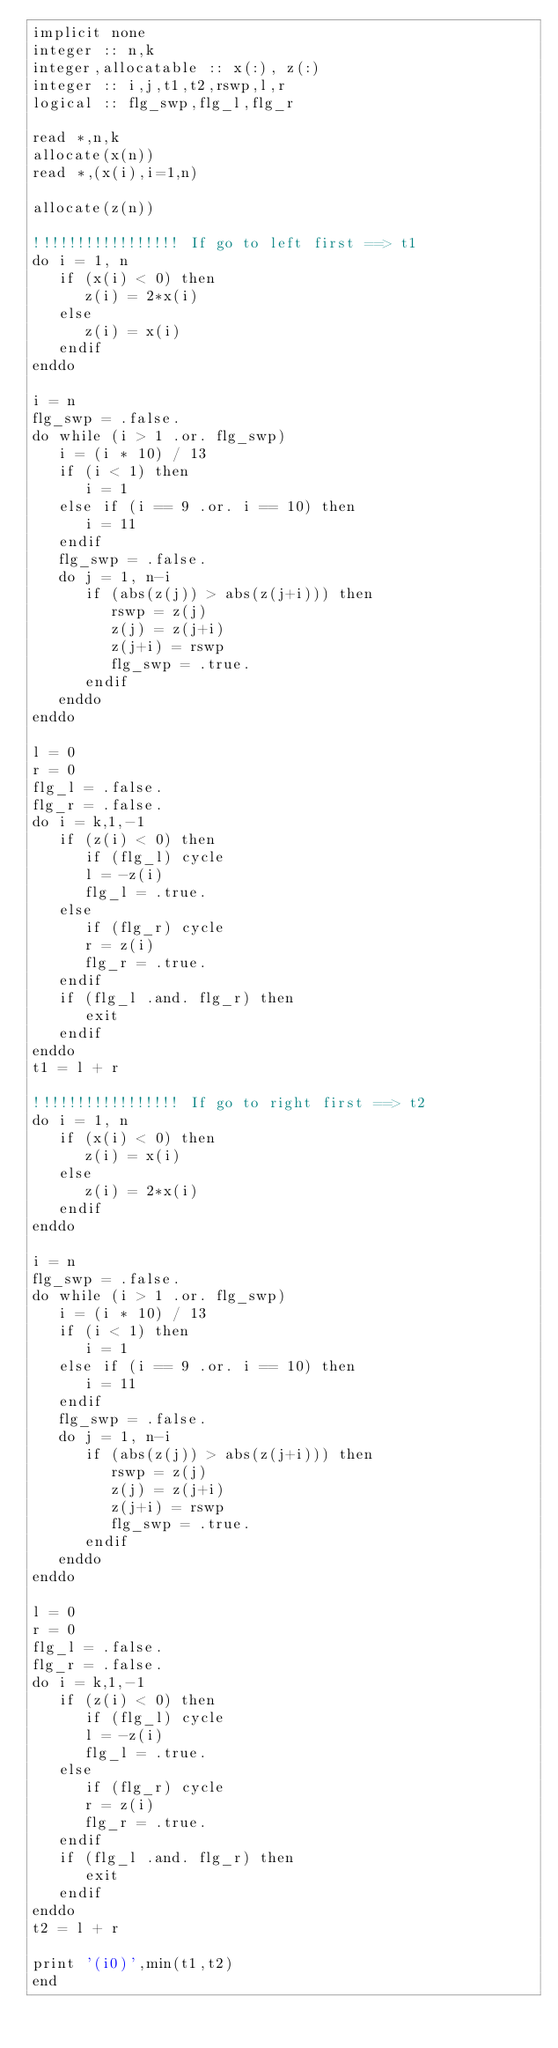Convert code to text. <code><loc_0><loc_0><loc_500><loc_500><_FORTRAN_>implicit none
integer :: n,k
integer,allocatable :: x(:), z(:)
integer :: i,j,t1,t2,rswp,l,r
logical :: flg_swp,flg_l,flg_r

read *,n,k
allocate(x(n))
read *,(x(i),i=1,n)

allocate(z(n))

!!!!!!!!!!!!!!!!! If go to left first ==> t1
do i = 1, n
   if (x(i) < 0) then
      z(i) = 2*x(i)
   else
      z(i) = x(i)
   endif
enddo

i = n
flg_swp = .false.
do while (i > 1 .or. flg_swp)
   i = (i * 10) / 13
   if (i < 1) then
      i = 1
   else if (i == 9 .or. i == 10) then 
      i = 11
   endif
   flg_swp = .false.
   do j = 1, n-i
      if (abs(z(j)) > abs(z(j+i))) then
         rswp = z(j) 
         z(j) = z(j+i)
         z(j+i) = rswp
         flg_swp = .true.
      endif
   enddo
enddo

l = 0
r = 0
flg_l = .false.
flg_r = .false.
do i = k,1,-1
   if (z(i) < 0) then
      if (flg_l) cycle
      l = -z(i)
      flg_l = .true.
   else
      if (flg_r) cycle
      r = z(i)
      flg_r = .true.
   endif
   if (flg_l .and. flg_r) then
      exit
   endif
enddo
t1 = l + r

!!!!!!!!!!!!!!!!! If go to right first ==> t2
do i = 1, n
   if (x(i) < 0) then
      z(i) = x(i)
   else
      z(i) = 2*x(i)
   endif
enddo

i = n
flg_swp = .false.
do while (i > 1 .or. flg_swp)
   i = (i * 10) / 13
   if (i < 1) then
      i = 1
   else if (i == 9 .or. i == 10) then 
      i = 11
   endif
   flg_swp = .false.
   do j = 1, n-i
      if (abs(z(j)) > abs(z(j+i))) then
         rswp = z(j) 
         z(j) = z(j+i)
         z(j+i) = rswp
         flg_swp = .true.
      endif
   enddo
enddo

l = 0
r = 0
flg_l = .false.
flg_r = .false.
do i = k,1,-1
   if (z(i) < 0) then
      if (flg_l) cycle
      l = -z(i)
      flg_l = .true.
   else
      if (flg_r) cycle
      r = z(i)
      flg_r = .true.
   endif
   if (flg_l .and. flg_r) then
      exit
   endif
enddo
t2 = l + r

print '(i0)',min(t1,t2)
end</code> 